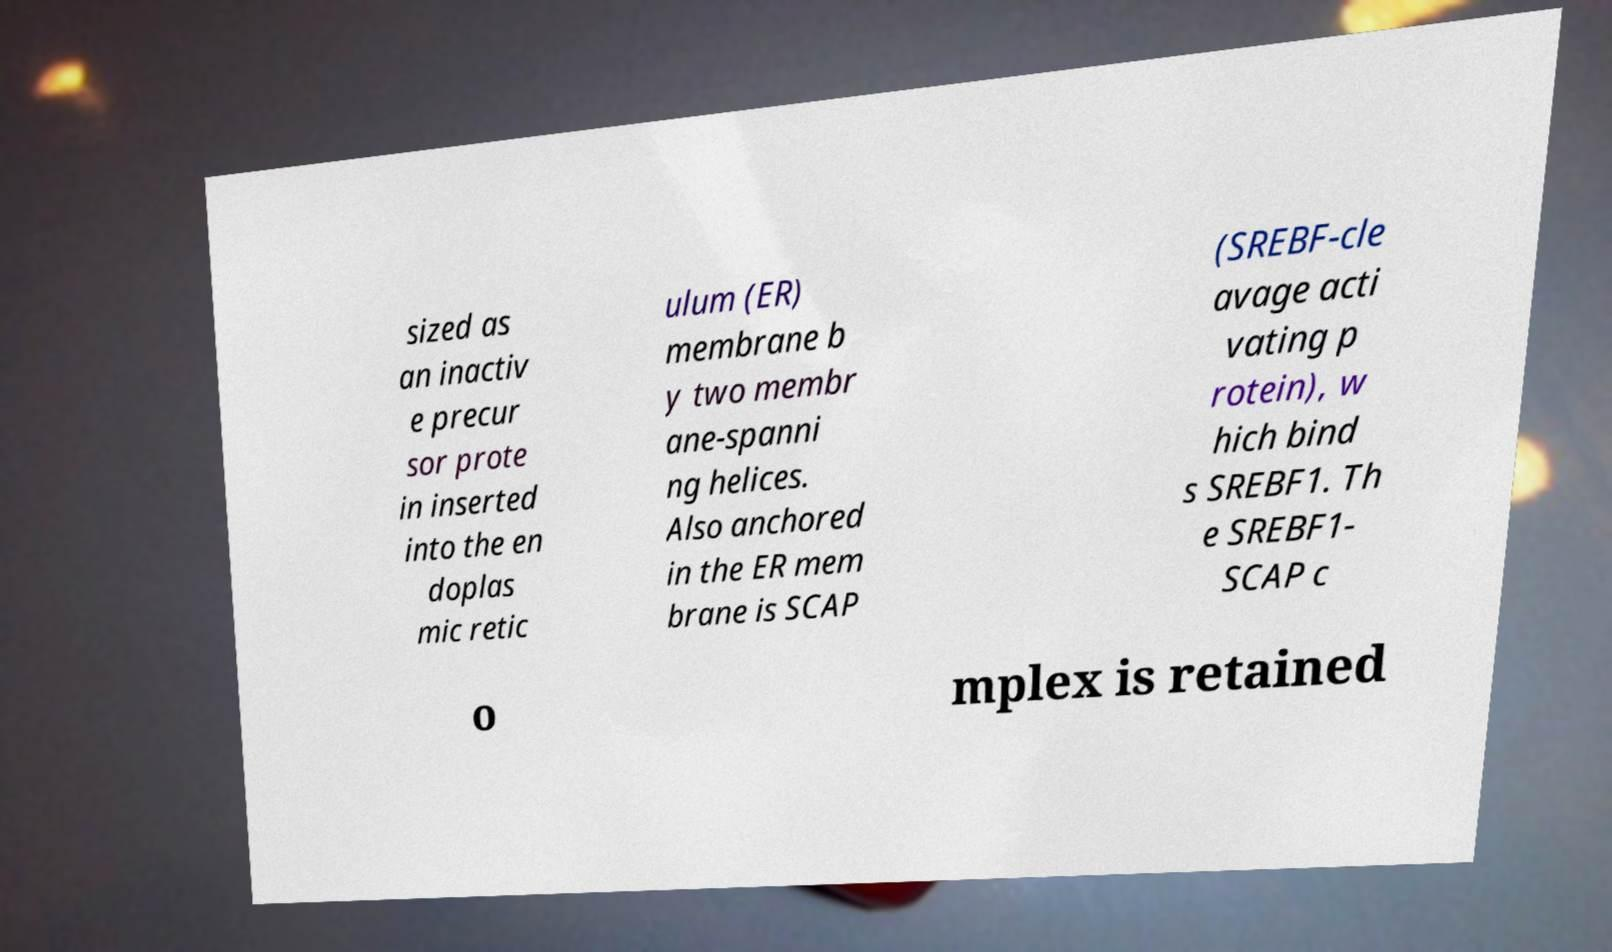Could you assist in decoding the text presented in this image and type it out clearly? sized as an inactiv e precur sor prote in inserted into the en doplas mic retic ulum (ER) membrane b y two membr ane-spanni ng helices. Also anchored in the ER mem brane is SCAP (SREBF-cle avage acti vating p rotein), w hich bind s SREBF1. Th e SREBF1- SCAP c o mplex is retained 